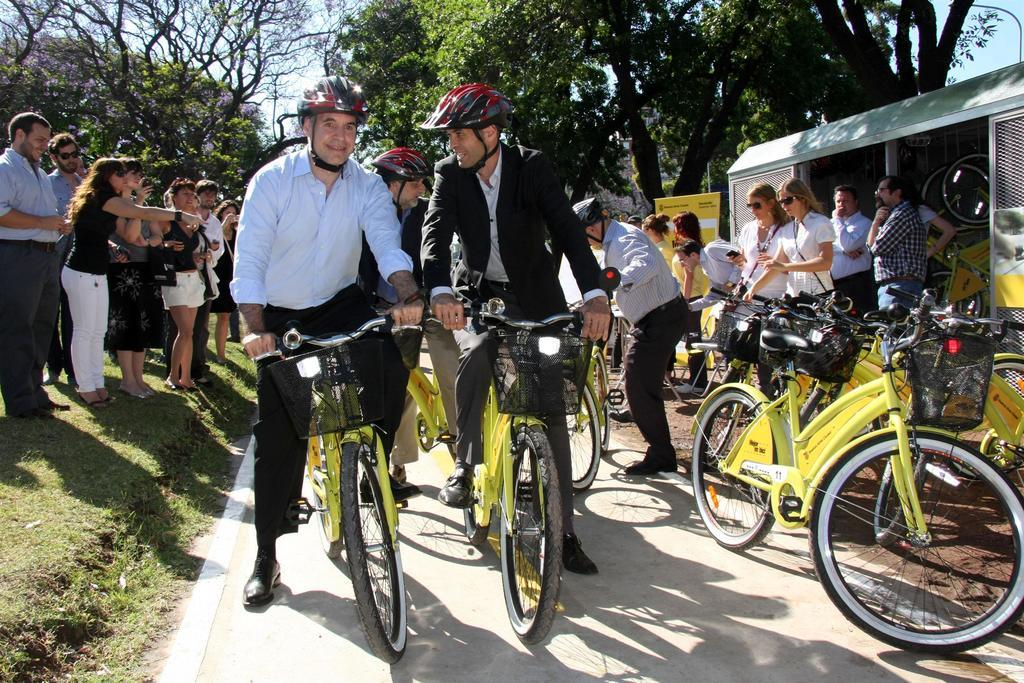How many men are in the image? There are two men in the image. What are the men doing in the image? The men are on a cycle in the image. Where are the men located in the image? The men are on a path in the image. What else can be seen in the image besides the men and the cycle? There are many cycles and people in the background of the image. What type of vegetation is visible in the background of the image? There are trees in the background of the image. What type of ink is being used by the men to write on the plough in the image? There is no ink or plough present in the image; the men are riding a cycle on a path. What type of drink is being consumed by the men while riding the cycle in the image? There is no drink present in the image; the men are simply riding the cycle. 